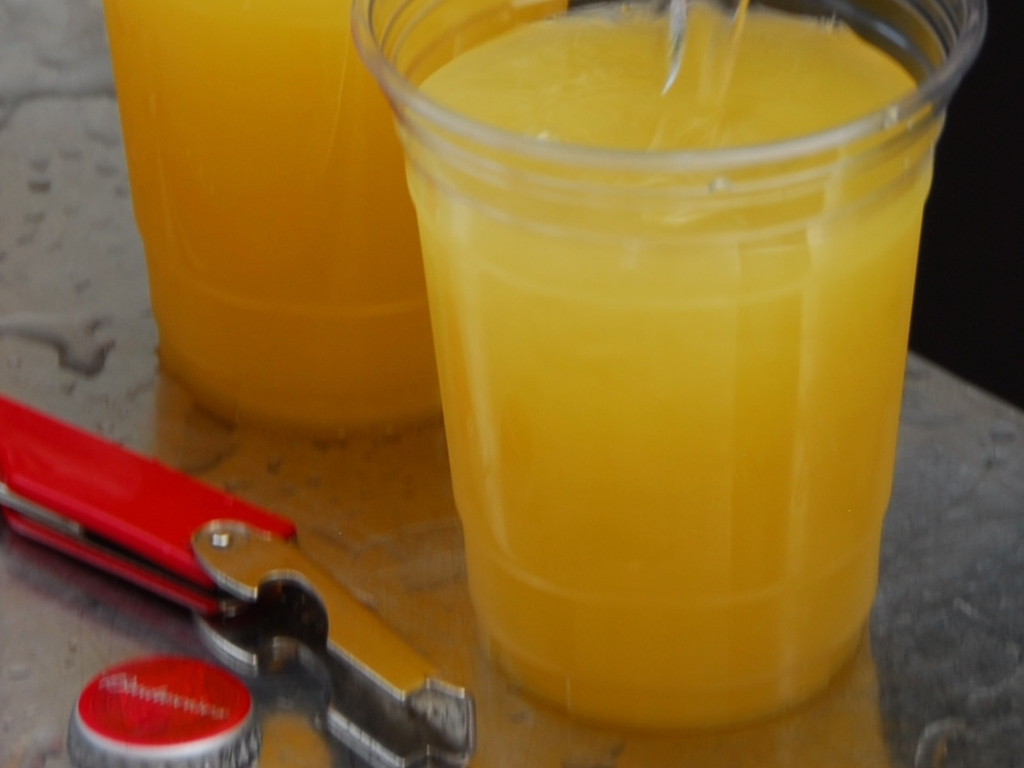Why does this photo seem to have been taken in a casual setting? The image gives off a casual vibe due to the visible kitchen tools on the side, like the bottle opener and can cover, and the simple plastic cups used to serve the beverage. These elements suggest an informal, perhaps domestic, environment rather than a professional setting. What could be the occasion for serving these drinks? Considering the simplicity of the presentation, the drinks could be for an everyday family meal, a small gathering at home, or even a quick refreshment break. The context doesn't indicate a special celebration but rather a routine occasion. 